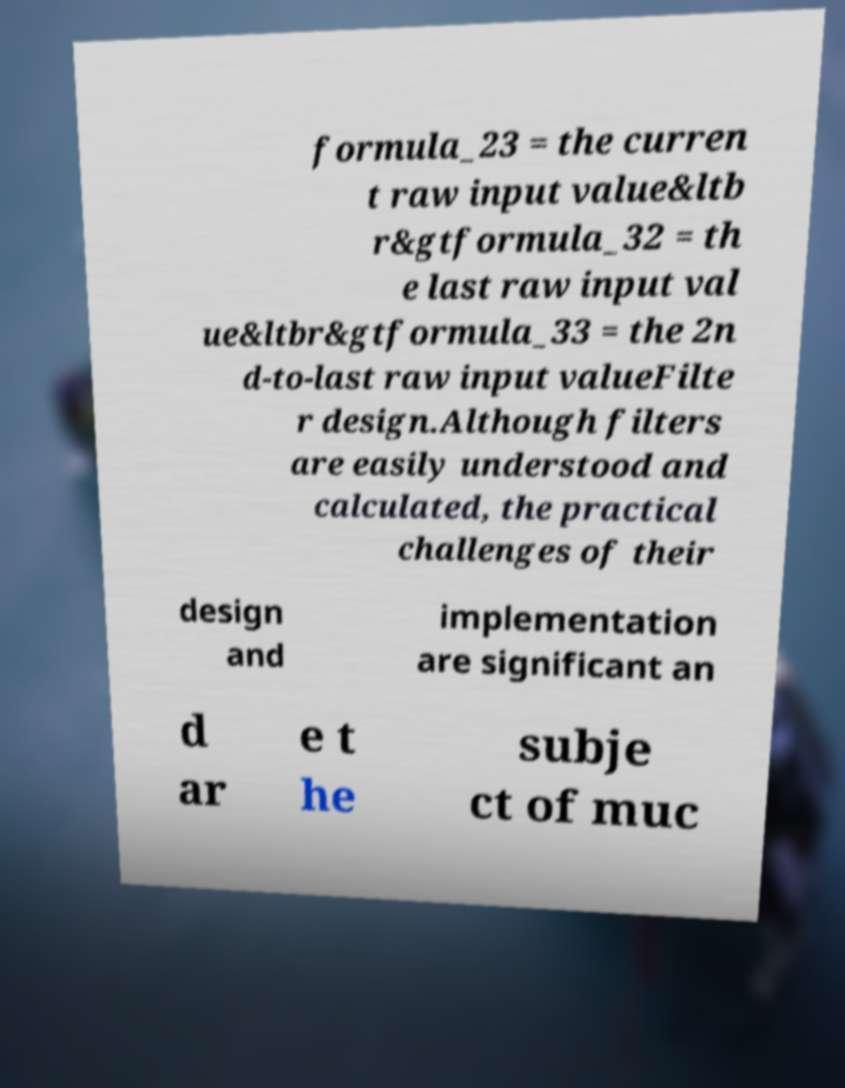Can you accurately transcribe the text from the provided image for me? formula_23 = the curren t raw input value&ltb r&gtformula_32 = th e last raw input val ue&ltbr&gtformula_33 = the 2n d-to-last raw input valueFilte r design.Although filters are easily understood and calculated, the practical challenges of their design and implementation are significant an d ar e t he subje ct of muc 